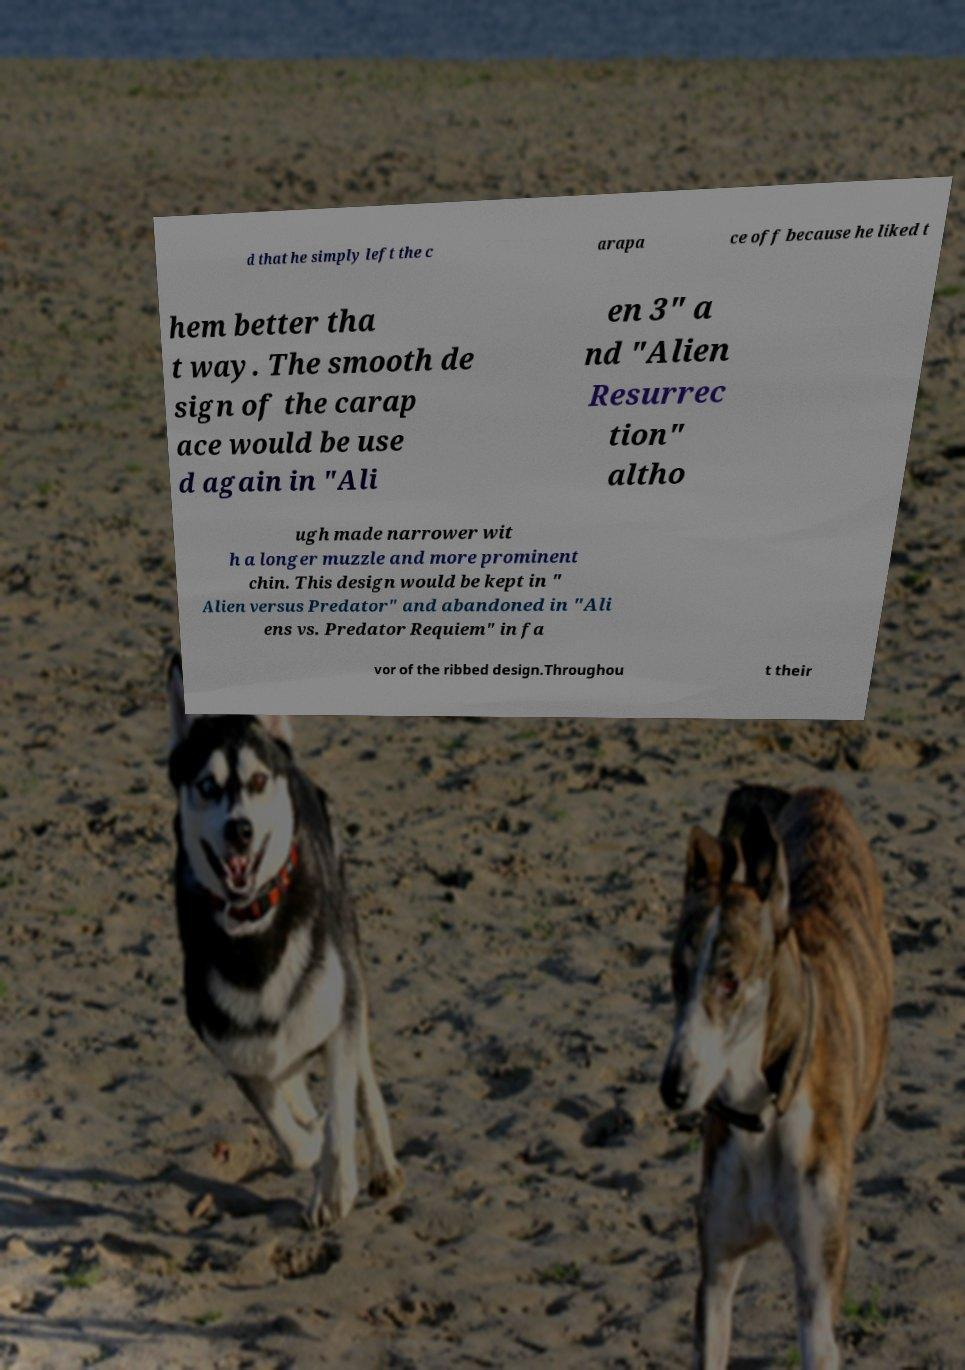Could you extract and type out the text from this image? d that he simply left the c arapa ce off because he liked t hem better tha t way. The smooth de sign of the carap ace would be use d again in "Ali en 3" a nd "Alien Resurrec tion" altho ugh made narrower wit h a longer muzzle and more prominent chin. This design would be kept in " Alien versus Predator" and abandoned in "Ali ens vs. Predator Requiem" in fa vor of the ribbed design.Throughou t their 